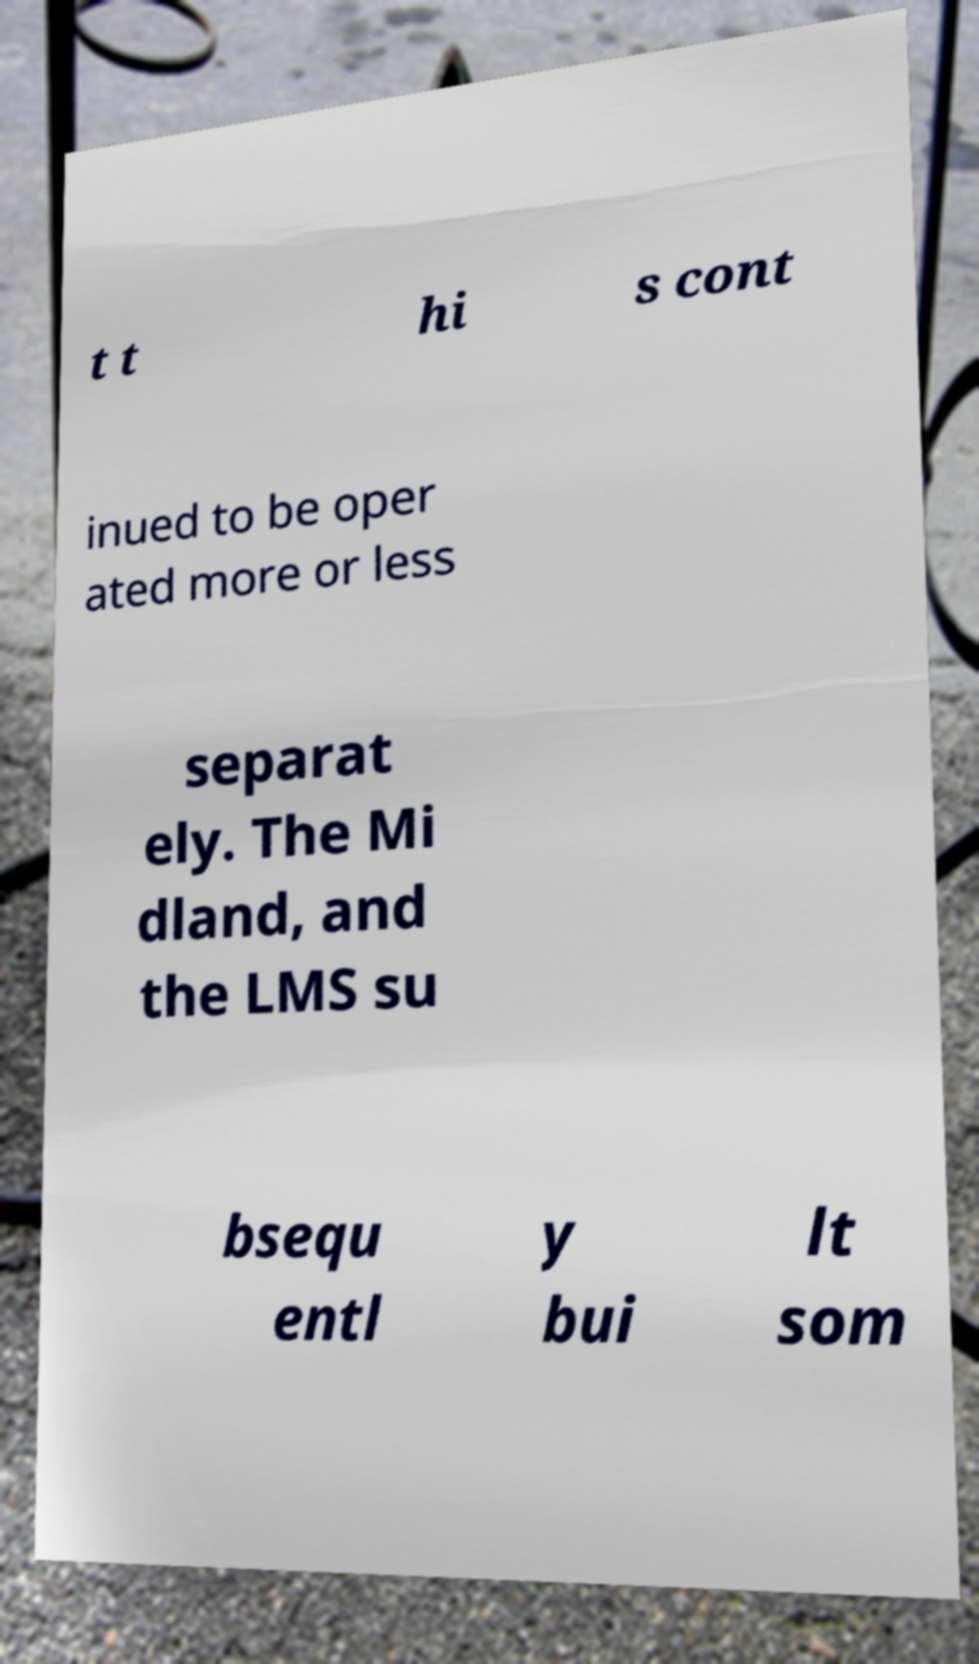What messages or text are displayed in this image? I need them in a readable, typed format. t t hi s cont inued to be oper ated more or less separat ely. The Mi dland, and the LMS su bsequ entl y bui lt som 